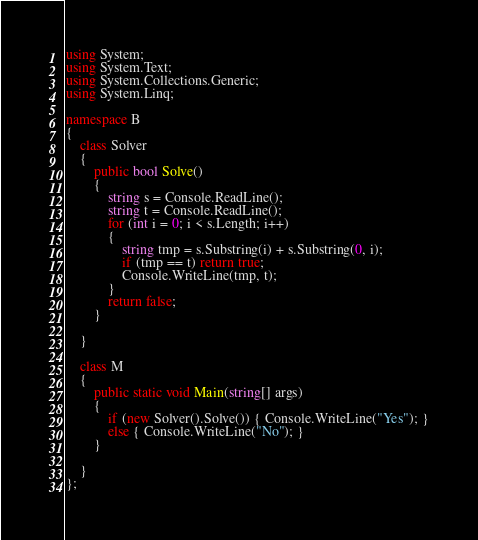<code> <loc_0><loc_0><loc_500><loc_500><_C#_>using System;
using System.Text;
using System.Collections.Generic;
using System.Linq;

namespace B
{
    class Solver
    {
        public bool Solve()
        {
            string s = Console.ReadLine();
            string t = Console.ReadLine();
            for (int i = 0; i < s.Length; i++)
            {
                string tmp = s.Substring(i) + s.Substring(0, i);
                if (tmp == t) return true;
                Console.WriteLine(tmp, t);
            }
            return false;
        }

    }

    class M
    {
        public static void Main(string[] args)
        {
            if (new Solver().Solve()) { Console.WriteLine("Yes"); }
            else { Console.WriteLine("No"); }
        }

    }
};
</code> 